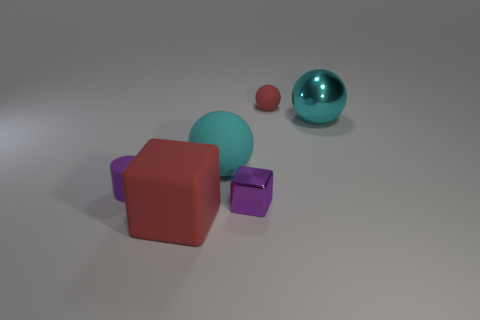Add 1 big cyan rubber objects. How many objects exist? 7 Subtract all blocks. How many objects are left? 4 Subtract all metallic cylinders. Subtract all large red cubes. How many objects are left? 5 Add 5 large shiny things. How many large shiny things are left? 6 Add 3 small blocks. How many small blocks exist? 4 Subtract 0 brown cubes. How many objects are left? 6 